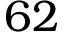<formula> <loc_0><loc_0><loc_500><loc_500>6 2</formula> 